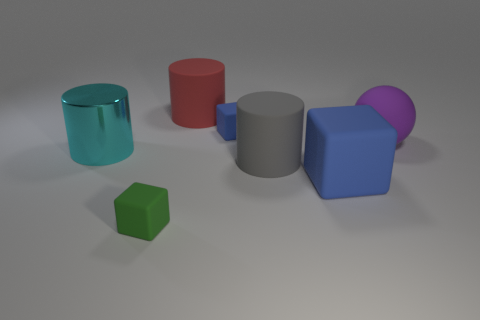Add 1 yellow rubber cylinders. How many objects exist? 8 Subtract 1 cylinders. How many cylinders are left? 2 Subtract all green blocks. How many blocks are left? 2 Subtract all big cyan metallic cylinders. How many cylinders are left? 2 Subtract 0 purple cylinders. How many objects are left? 7 Subtract all cylinders. How many objects are left? 4 Subtract all cyan spheres. Subtract all red cylinders. How many spheres are left? 1 Subtract all yellow blocks. How many red cylinders are left? 1 Subtract all green metallic spheres. Subtract all large red things. How many objects are left? 6 Add 1 big matte balls. How many big matte balls are left? 2 